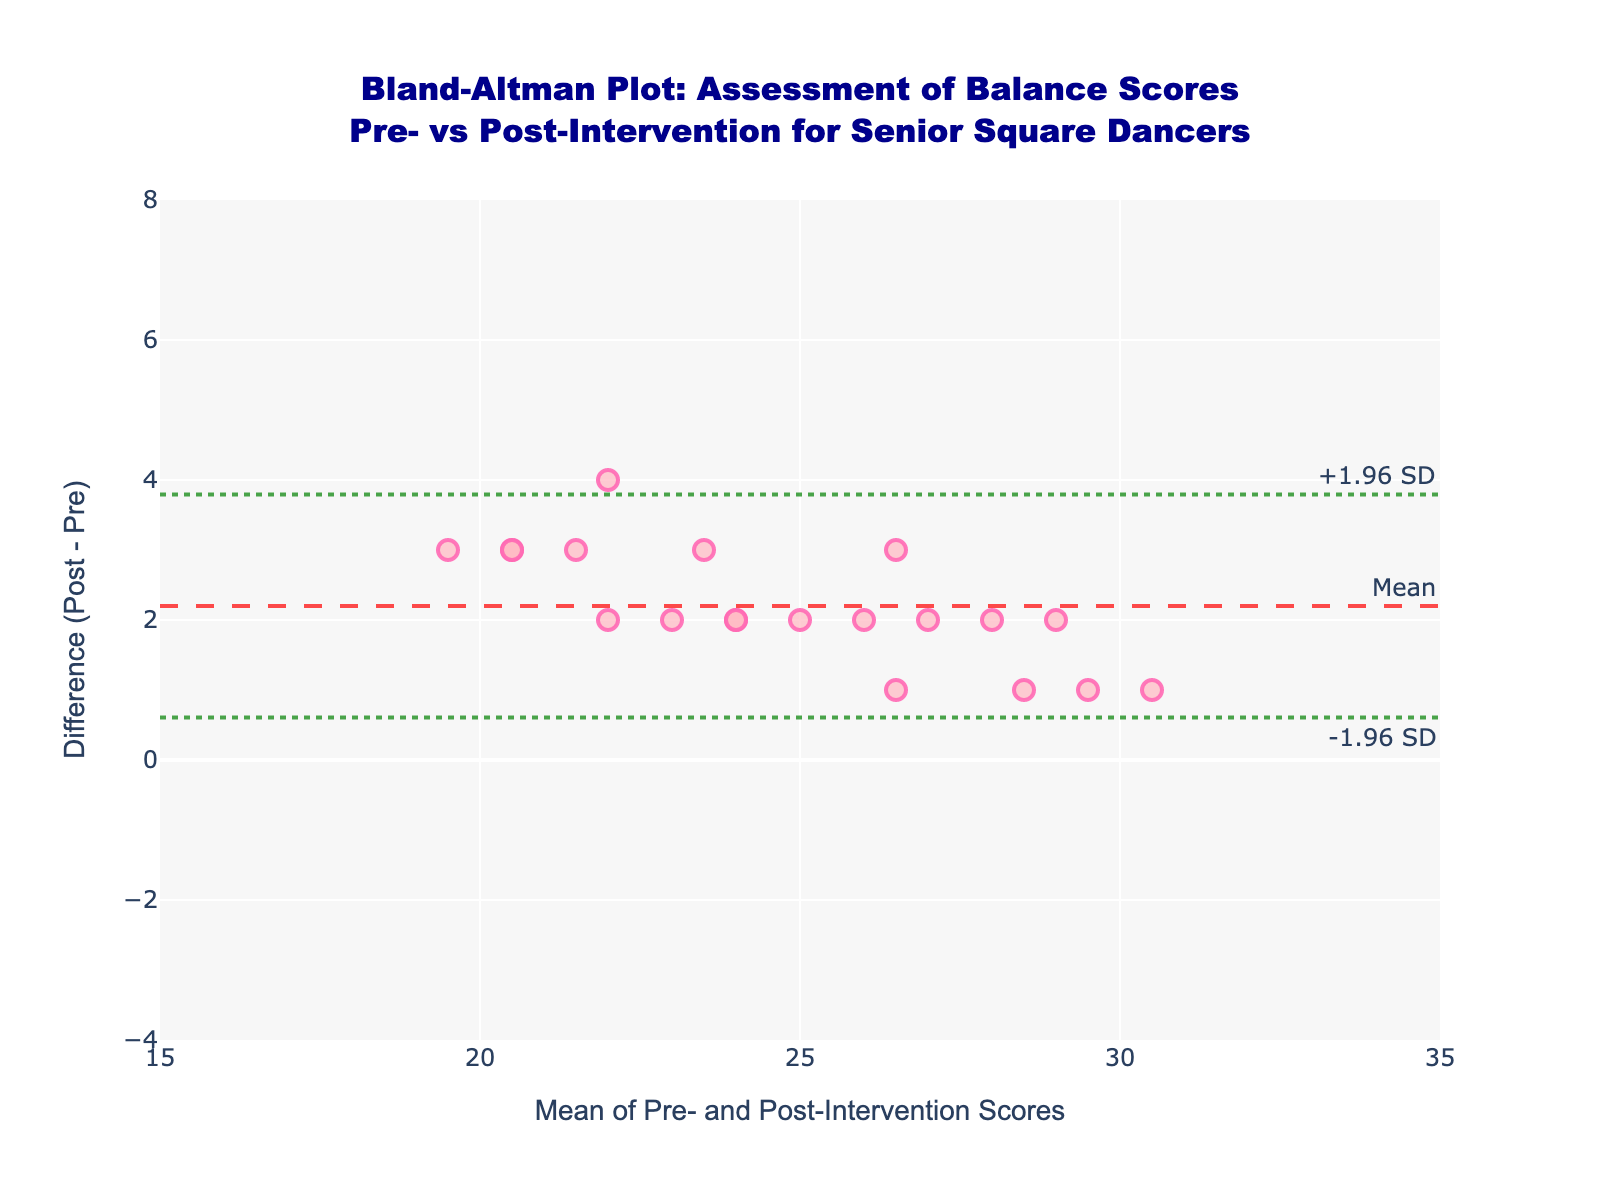How many data points are plotted in the Bland-Altman plot? To find the number of data points, simply count the total number of markers on the plot.
Answer: 20 What's the title of the plot? The title is positioned at the top center of the plot and often mentions the primary subject and context.
Answer: Bland-Altman Plot: Assessment of Balance Scores Pre- vs Post-Intervention for Senior Square Dancers What do the dashed and dotted horizontal lines represent? The dashed line indicates the mean difference, and the dotted lines represent the limits of agreement (±1.96 standard deviations from the mean difference).
Answer: Mean difference and ±1.96 SD limits What is the mean difference in the plot? Look for the dashed horizontal line, often annotated as "Mean." The y-coordinate of this line gives the mean difference.
Answer: 2 What are the upper and lower limits of agreement? Look for the dotted horizontal lines often annotated with "+1.96 SD" and "-1.96 SD." The y-coordinates of these lines give the upper and lower limits of agreement.
Answer: Upper: 4.92, Lower: -0.92 Is there any data point with a mean score between 15 and 20? Observe the x-axis for the range 15 to 20 and check if any markers (data points) fall within this range.
Answer: Yes Which data points have the highest mean score, and what is the difference for this point? Identify the data point at the highest x-axis value (mean score) and then check the corresponding y-axis value (difference).
Answer: Mean score: 30.5, Difference: 1 Are there any data points that fall outside the limits of agreement? Look at the scatter points and see if any of them fall above the upper limit (+1.96 SD) or below the lower limit (-1.96 SD).
Answer: No What can be inferred if most data points lie within the limits of agreement? This suggests good agreement between pre- and post-intervention balance scores as the differences mostly lie within the expected range of variation.
Answer: Good agreement Which mean score range has the highest concentration of data points? Visually inspect the plot to see where most of the markers (data points) cluster on the x-axis.
Answer: 22.5 to 27.5 